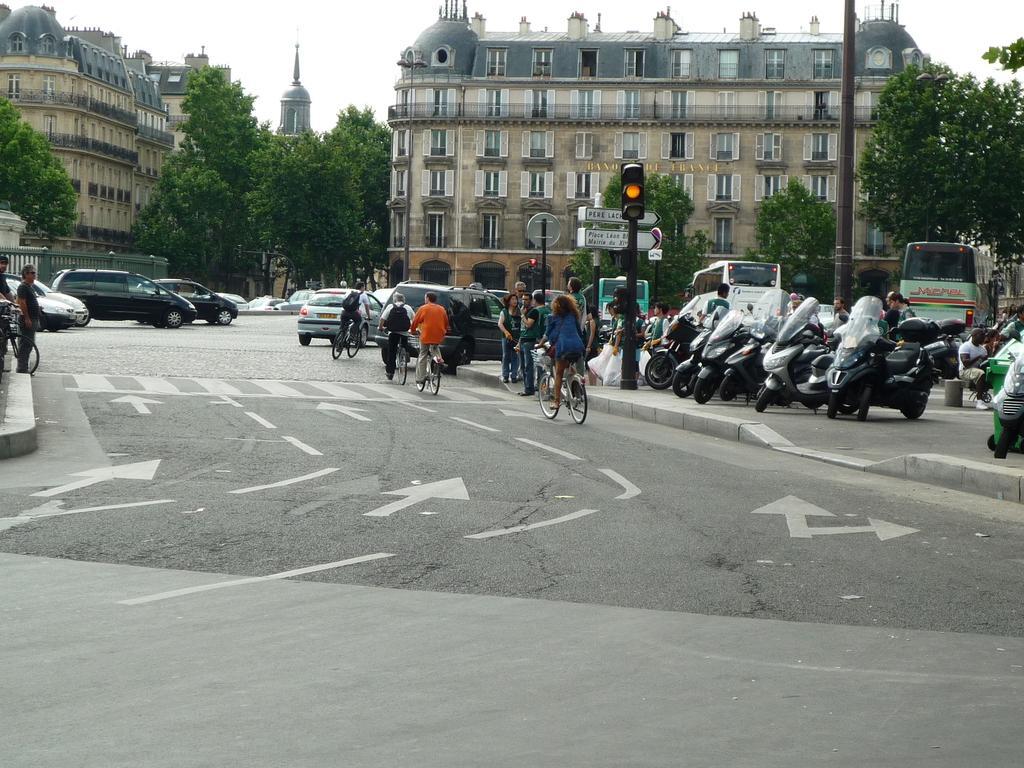Describe this image in one or two sentences. In this image there are a few people riding bicycles on the road and there are cars, buses and other vehicles passing on the road, beside the road on the pavement there are a few pedestrians walking, in this image we can see lamp posts, traffic lights, sign boards, trees and buildings. 